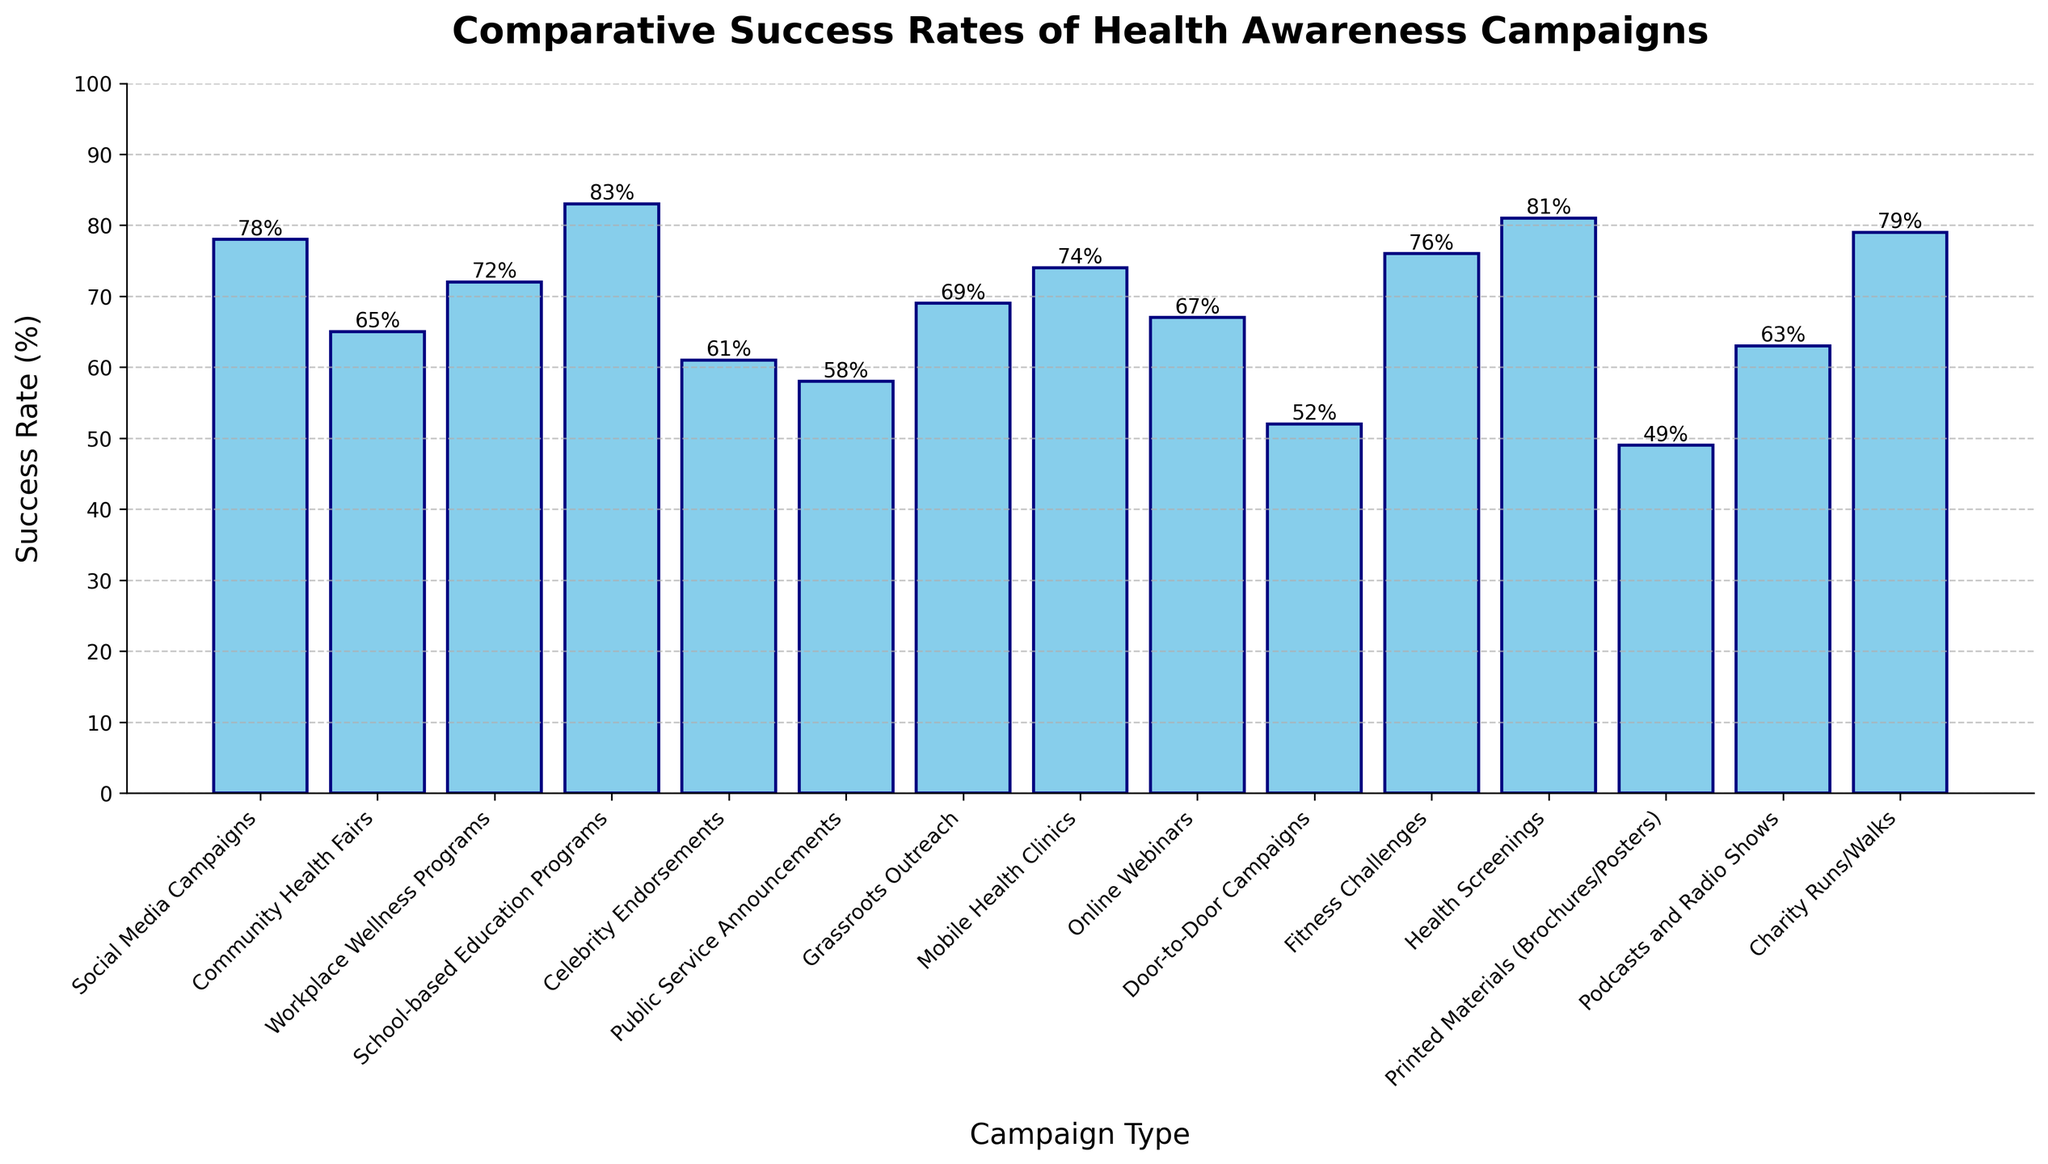Which campaign type has the highest success rate? Look for the tallest bar in the bar chart. The tallest bar represents School-based Education Programs at 83%.
Answer: School-based Education Programs Which campaign type has the lowest success rate? Find the shortest bar in the bar chart. The shortest bar represents Printed Materials (Brochures/Posters) at 49%.
Answer: Printed Materials (Brochures/Posters) What is the difference in success rate between School-based Education Programs and Door-to-Door Campaigns? The success rate of School-based Education Programs is 83%, and for Door-to-Door Campaigns, it is 52%. Subtract the smaller rate from the larger one: 83% - 52% = 31%.
Answer: 31% Which has a higher success rate: Charity Runs/Walks or Community Health Fairs, and by how much? Look at the bars for Charity Runs/Walks (79%) and Community Health Fairs (65%). Charity Runs/Walks have a higher success rate. Subtract the smaller rate from the larger one: 79% - 65% = 14%.
Answer: Charity Runs/Walks by 14% What is the average success rate for Social Media Campaigns, Celebrity Endorsements, and Public Service Announcements? Add the success rates of the three campaigns: 78% (Social Media Campaigns) + 61% (Celebrity Endorsements) + 58% (Public Service Announcements) = 197%. Divide by the number of campaigns: 197% / 3 ≈ 65.67%.
Answer: 65.67% Which campaign type has a success rate greater than 70% but less than 80%? Look for bars within this range: Social Media Campaigns (78%), Workplace Wellness Programs (72%), Fitness Challenges (76%), Health Screenings (81%), and Charity Runs/Walks (79%). Only Social Media Campaigns, Workplace Wellness Programs, and Fitness Challenges fit the criteria.
Answer: Social Media Campaigns, Workplace Wellness Programs, Fitness Challenges What is the combined success rate of Grassroots Outreach and Mobile Health Clinics? Add the success rates of the two campaigns: 69% (Grassroots Outreach) + 74% (Mobile Health Clinics) = 143%.
Answer: 143% Are there more campaigns with a success rate above or below 70%? Count the bars: Above 70%: Social Media Campaigns, Workplace Wellness Programs, School-based Education Programs, Mobile Health Clinics, Fitness Challenges, Health Screenings, Charity Runs/Walks (7 campaigns). Below 70%: Community Health Fairs, Celebrity Endorsements, Public Service Announcements, Grassroots Outreach, Online Webinars, Door-to-Door Campaigns, Printed Materials, Podcasts and Radio Shows (8 campaigns).
Answer: Below 70% Which two campaign types have success rates closest to each other, and what are their rates? Compare the success rates numerically to see the smallest difference: Community Health Fairs (65%) and Online Webinars (67%) have a difference of 2%.
Answer: Community Health Fairs (65%) and Online Webinars (67%) What is the median success rate of the campaign types listed? Organize the success rates in ascending order: [49, 52, 58, 61, 63, 65, 67, 69, 72, 74, 76, 78, 79, 81, 83]. The median value is the middle one in the list: 69%.
Answer: 69% 